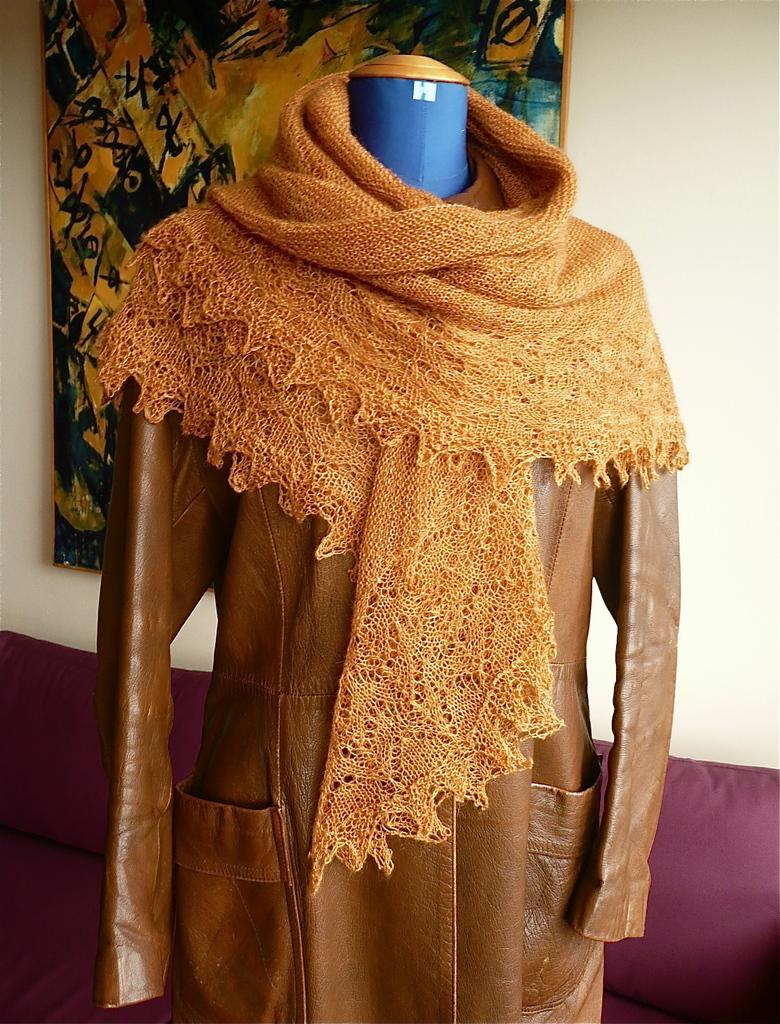What is the main subject in the center of the image? There is a mannequin in the center of the image. What is located near the mannequin? There is a scarf and a dress near the mannequin. What can be seen on the wall in the background of the image? There is a frame on the wall in the background of the image. What type of furniture is at the bottom of the image? There is a couch at the bottom of the image. Can you see any fairies driving a base in the image? No, there are no fairies, driving, or bases present in the image. 